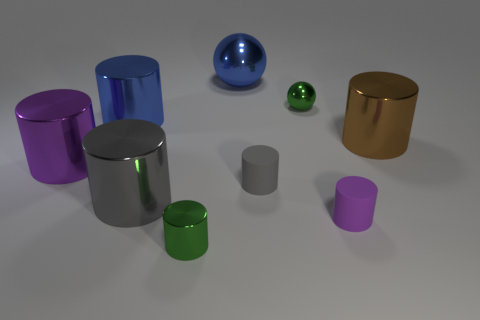What is the color of the large cylinder that is on the right side of the green shiny cylinder?
Make the answer very short. Brown. There is a gray cylinder that is behind the gray shiny thing; does it have the same size as the green shiny thing that is behind the purple matte thing?
Give a very brief answer. Yes. How many objects are either large purple metallic objects or large gray rubber cylinders?
Offer a very short reply. 1. There is a purple thing that is to the right of the green metallic thing on the right side of the green cylinder; what is its material?
Offer a very short reply. Rubber. How many gray rubber things are the same shape as the big brown object?
Offer a terse response. 1. Are there any other big metallic balls of the same color as the large metallic sphere?
Your answer should be very brief. No. How many objects are either shiny things that are behind the brown shiny thing or cylinders that are on the left side of the small purple rubber thing?
Provide a succinct answer. 7. There is a purple cylinder that is to the right of the big blue shiny ball; is there a green metal thing that is in front of it?
Keep it short and to the point. Yes. What is the shape of the purple object that is the same size as the gray metal thing?
Provide a short and direct response. Cylinder. How many things are tiny things that are in front of the green metallic ball or purple rubber objects?
Your answer should be very brief. 3. 